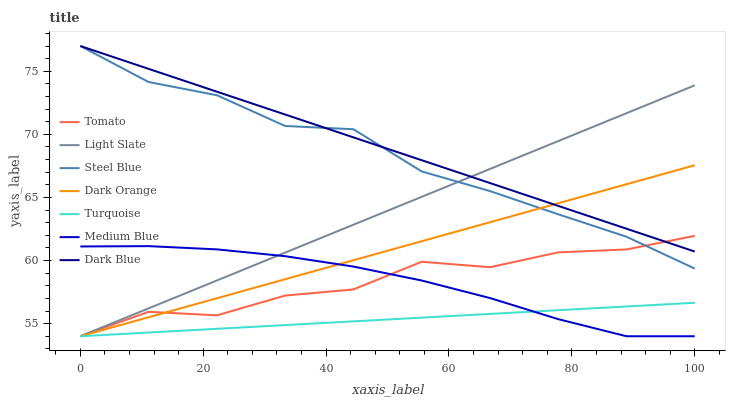Does Turquoise have the minimum area under the curve?
Answer yes or no. Yes. Does Dark Blue have the maximum area under the curve?
Answer yes or no. Yes. Does Dark Orange have the minimum area under the curve?
Answer yes or no. No. Does Dark Orange have the maximum area under the curve?
Answer yes or no. No. Is Turquoise the smoothest?
Answer yes or no. Yes. Is Tomato the roughest?
Answer yes or no. Yes. Is Dark Orange the smoothest?
Answer yes or no. No. Is Dark Orange the roughest?
Answer yes or no. No. Does Steel Blue have the lowest value?
Answer yes or no. No. Does Dark Blue have the highest value?
Answer yes or no. Yes. Does Dark Orange have the highest value?
Answer yes or no. No. Is Turquoise less than Dark Blue?
Answer yes or no. Yes. Is Dark Blue greater than Turquoise?
Answer yes or no. Yes. Does Dark Blue intersect Steel Blue?
Answer yes or no. Yes. Is Dark Blue less than Steel Blue?
Answer yes or no. No. Is Dark Blue greater than Steel Blue?
Answer yes or no. No. Does Turquoise intersect Dark Blue?
Answer yes or no. No. 